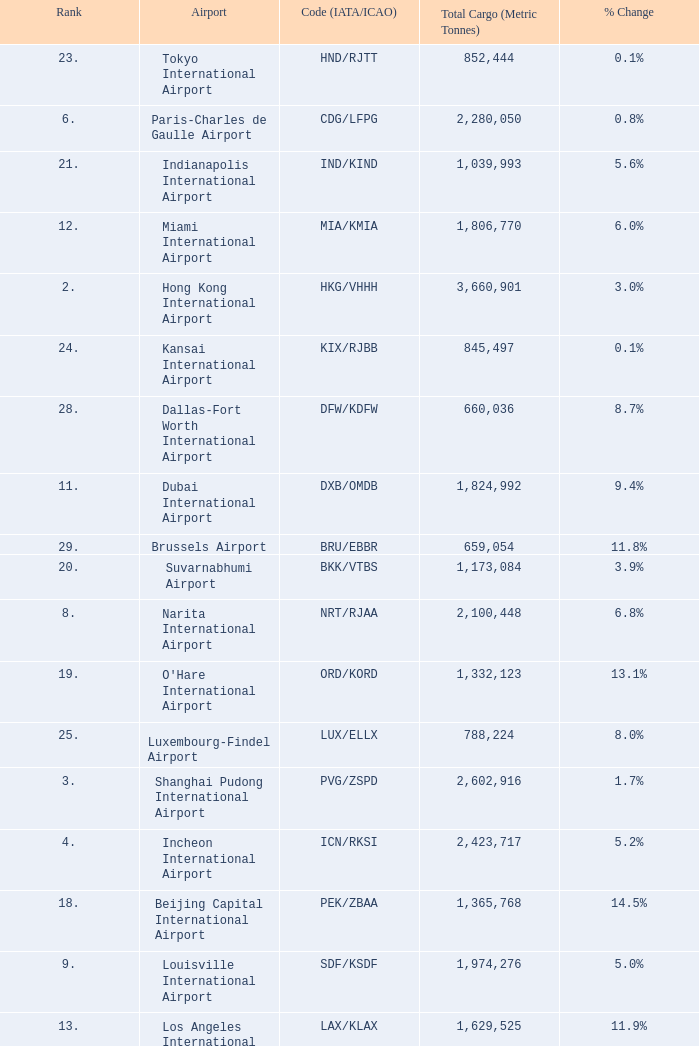What is the code for rank 10? SIN/WSSS. 